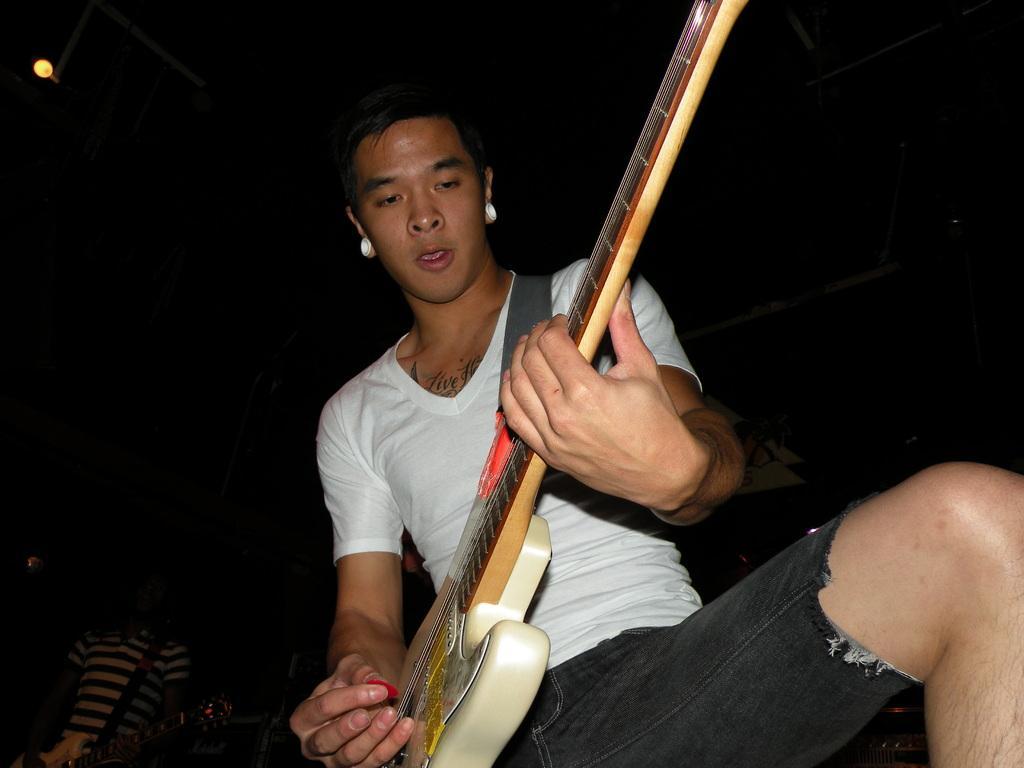Please provide a concise description of this image. Background is completely dark. We can see a light here. Here we can see one man wearing a white colour shirt and playing guitar. 